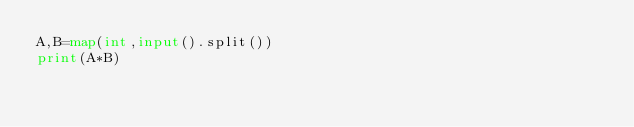<code> <loc_0><loc_0><loc_500><loc_500><_Python_>A,B=map(int,input().split())
print(A*B)</code> 